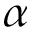<formula> <loc_0><loc_0><loc_500><loc_500>\alpha</formula> 